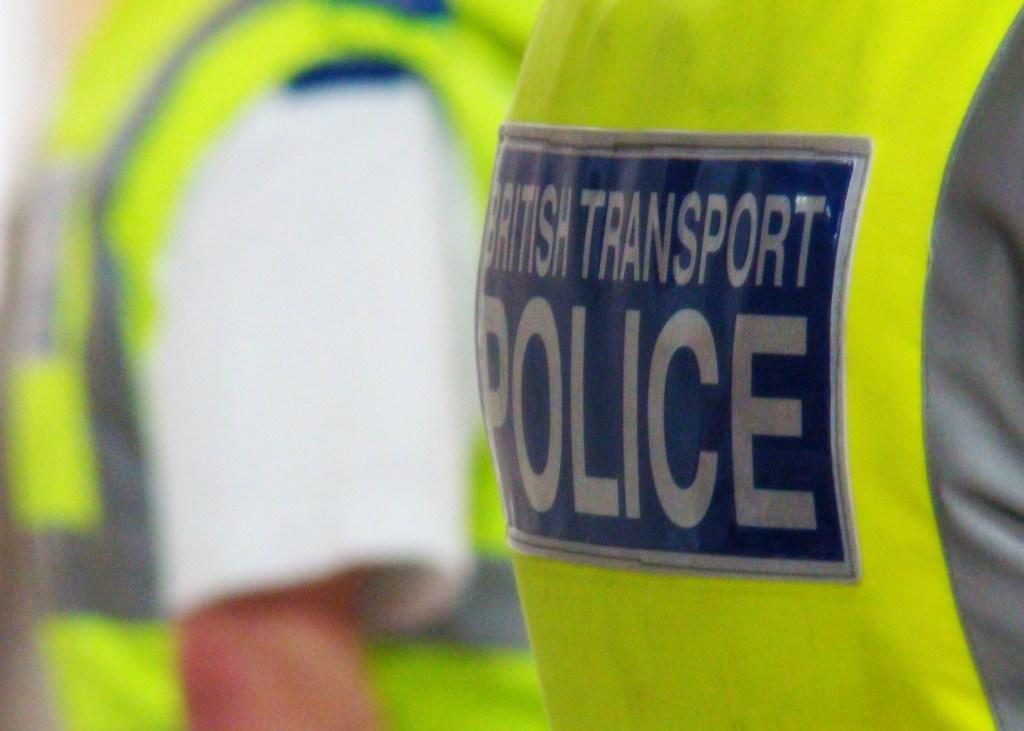<image>
Describe the image concisely. Person wearing a green vest that says POLICE on it. 